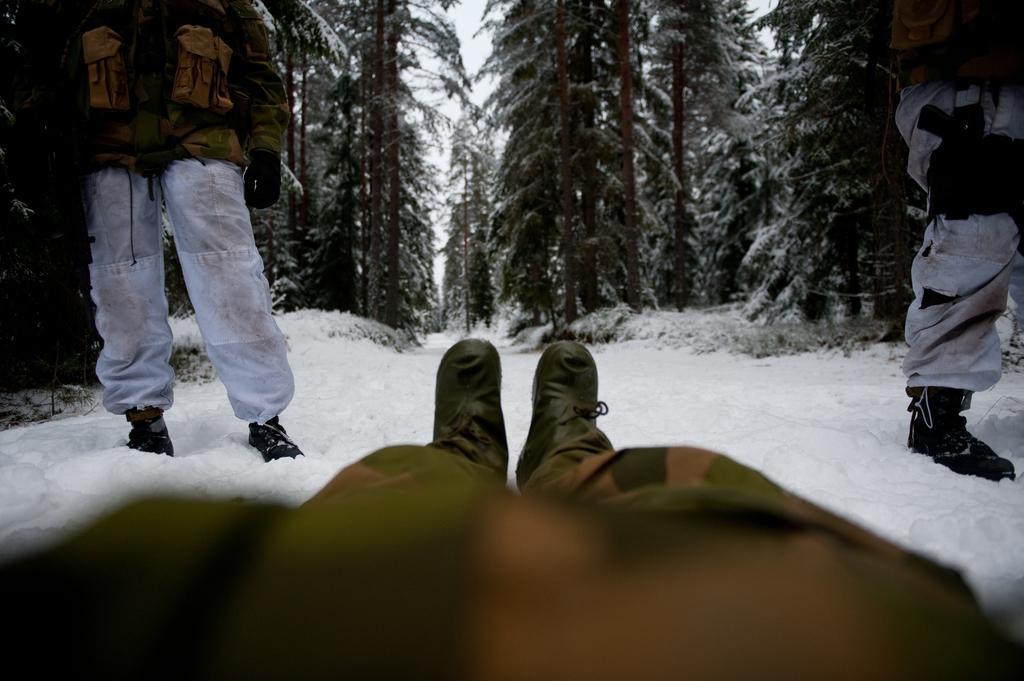Please provide a concise description of this image. In front of the image there is a person lying on the surface of the snow. In front of him there are two people standing. In the background of the image there are trees and sky. 